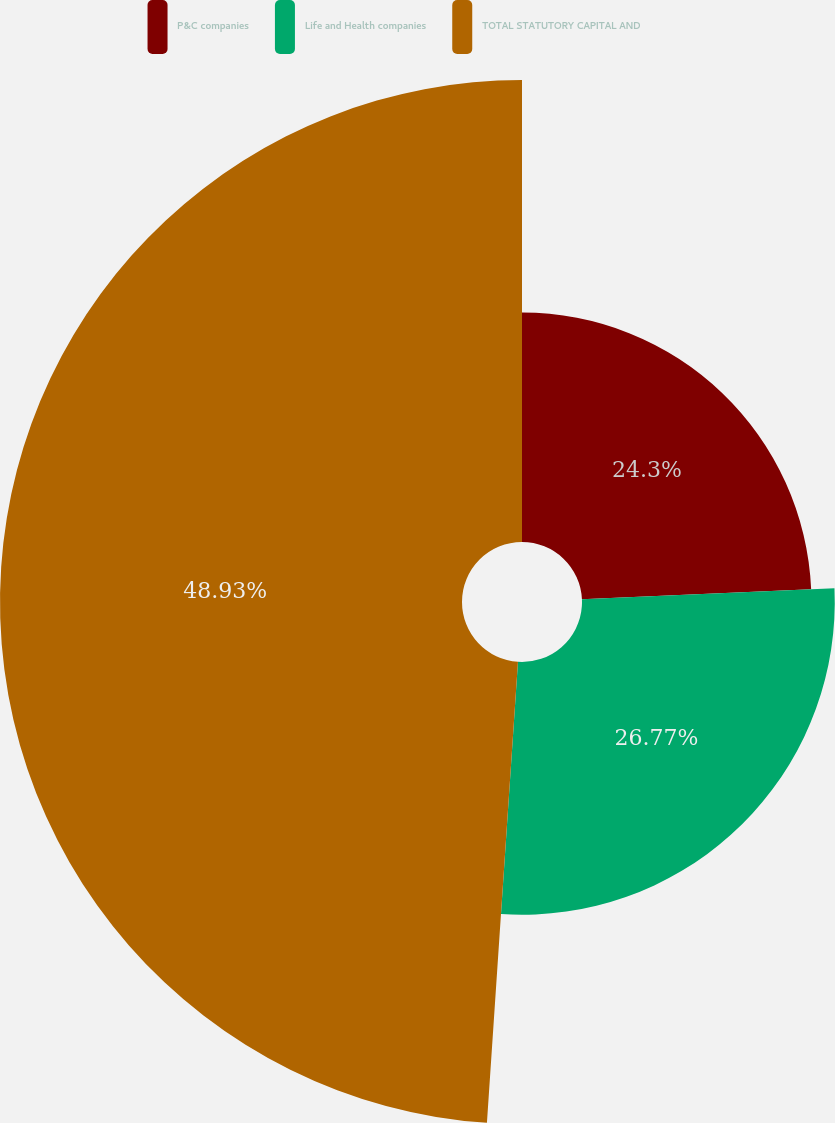Convert chart. <chart><loc_0><loc_0><loc_500><loc_500><pie_chart><fcel>P&C companies<fcel>Life and Health companies<fcel>TOTAL STATUTORY CAPITAL AND<nl><fcel>24.3%<fcel>26.77%<fcel>48.93%<nl></chart> 